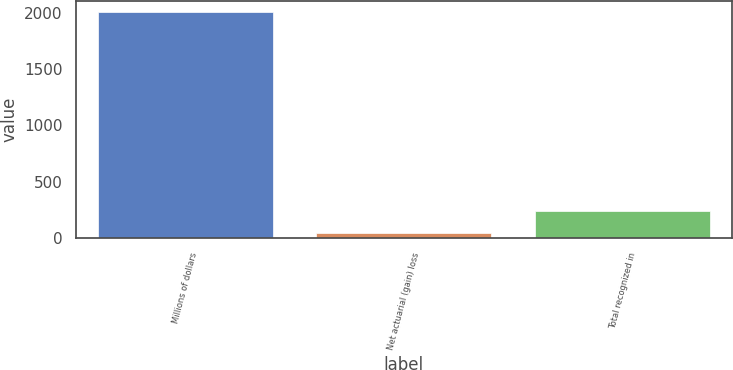<chart> <loc_0><loc_0><loc_500><loc_500><bar_chart><fcel>Millions of dollars<fcel>Net actuarial (gain) loss<fcel>Total recognized in<nl><fcel>2007<fcel>39<fcel>235.8<nl></chart> 